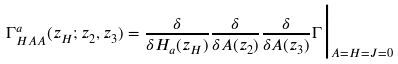<formula> <loc_0><loc_0><loc_500><loc_500>\Gamma ^ { a } _ { H A A } ( z _ { H } ; z _ { 2 } , z _ { 3 } ) = \frac { \delta } { \delta H _ { a } ( z _ { H } ) } \frac { \delta } { \delta A ( z _ { 2 } ) } \frac { \delta } { \delta A ( z _ { 3 } ) } \Gamma \Big | _ { A = H = J = 0 }</formula> 